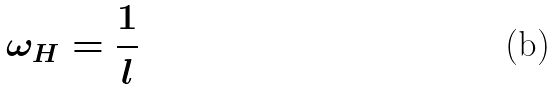<formula> <loc_0><loc_0><loc_500><loc_500>\omega _ { H } = \frac { 1 } { l } \,</formula> 